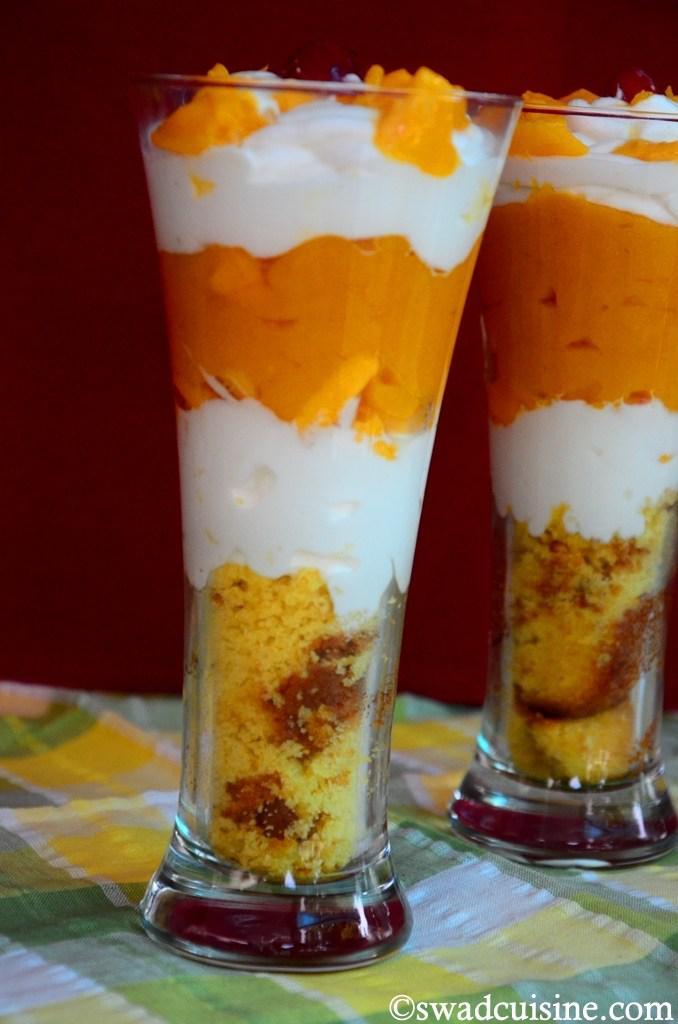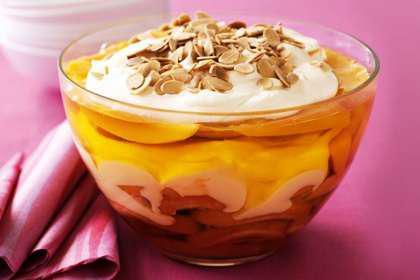The first image is the image on the left, the second image is the image on the right. Considering the images on both sides, is "there are 2 parfaits on the right image" valid? Answer yes or no. No. 